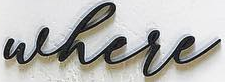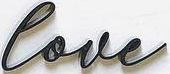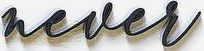What words can you see in these images in sequence, separated by a semicolon? where; love; never 